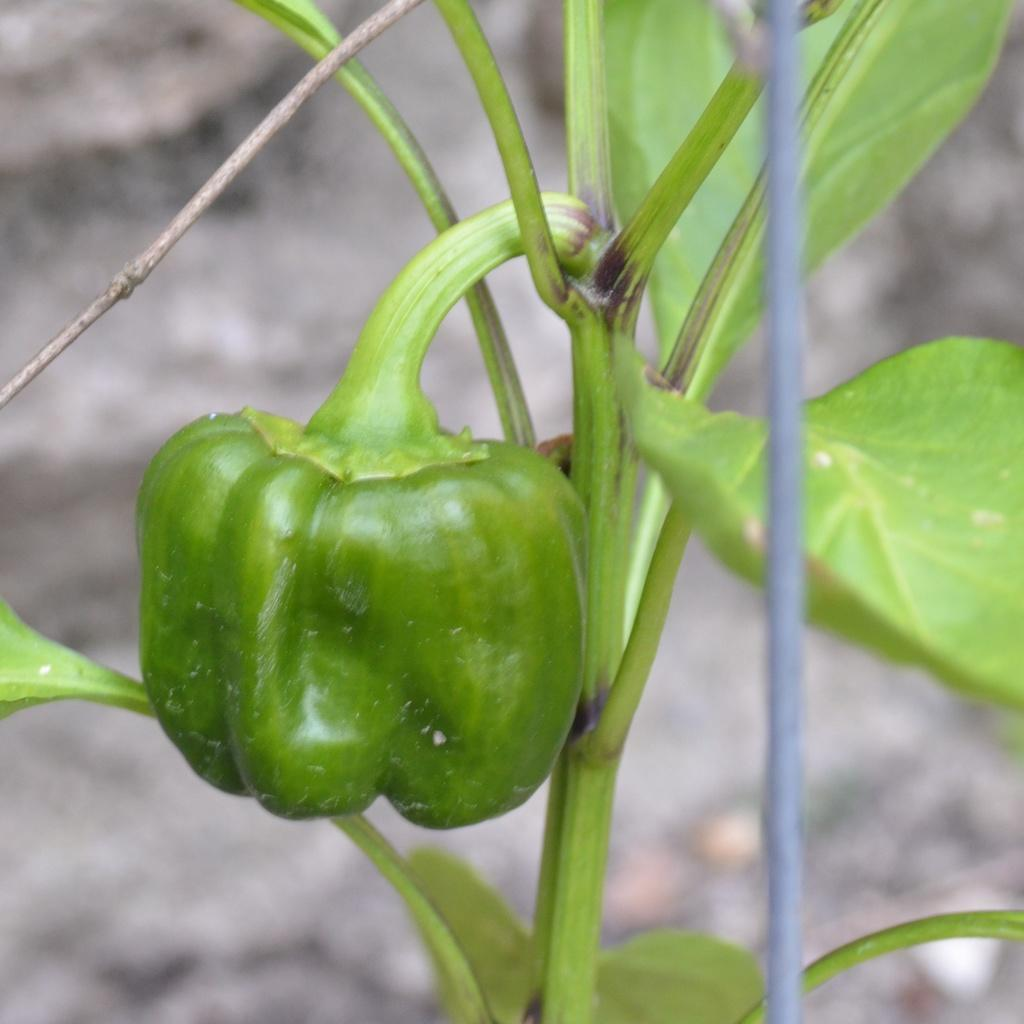What type of living organism can be seen in the image? There is a plant in the image. What type of vegetable is present in the image? There is a capsicum vegetable in the image. How would you describe the background of the image? The background of the image is blurred. How many dimes can be seen on the plant in the image? There are no dimes present in the image; it features a plant and a capsicum vegetable. Is there an airplane visible in the image? No, there is no airplane present in the image. 